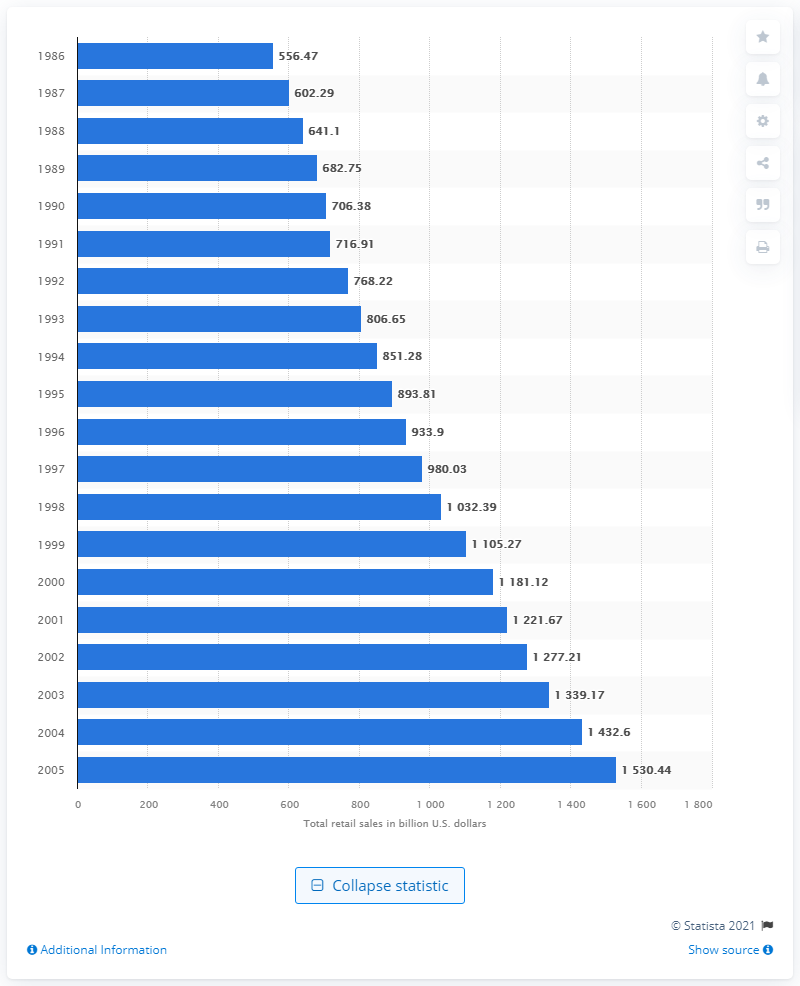Specify some key components in this picture. The total retail sales of shopping malls in the United States in 1986 was 556.47. 